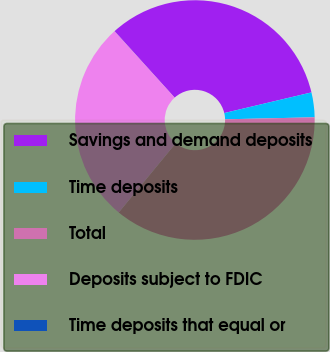Convert chart to OTSL. <chart><loc_0><loc_0><loc_500><loc_500><pie_chart><fcel>Savings and demand deposits<fcel>Time deposits<fcel>Total<fcel>Deposits subject to FDIC<fcel>Time deposits that equal or<nl><fcel>33.0%<fcel>3.34%<fcel>36.33%<fcel>27.33%<fcel>0.01%<nl></chart> 